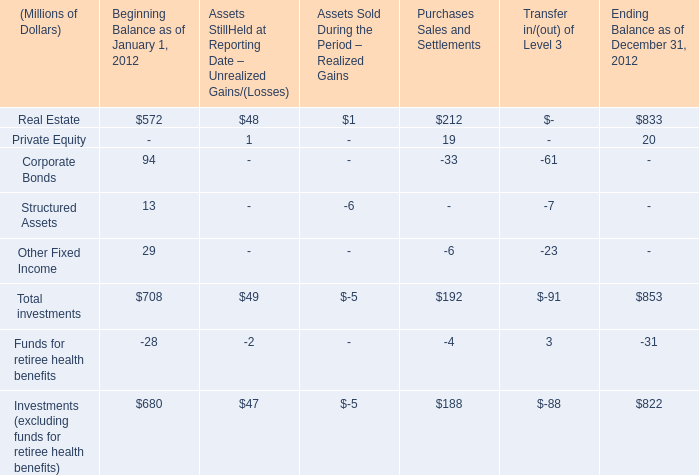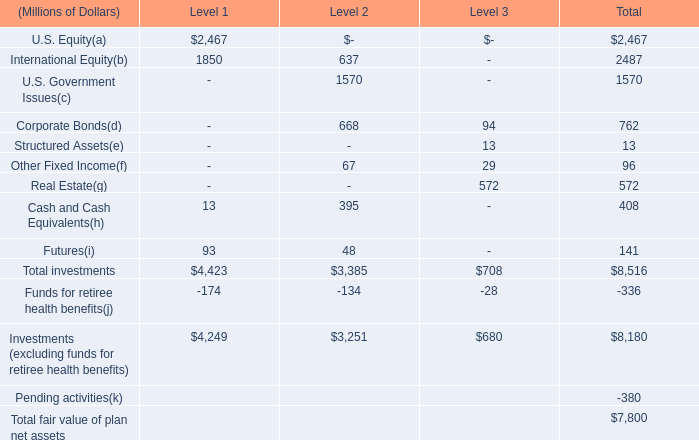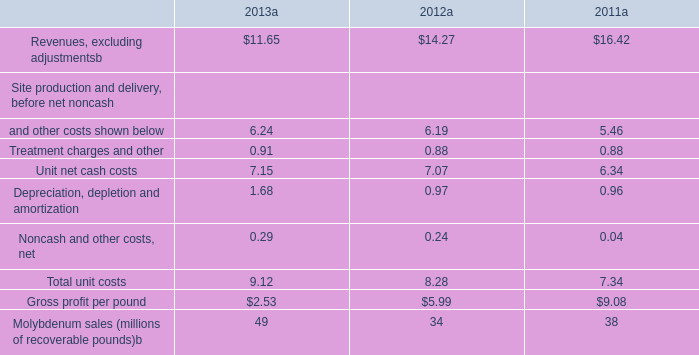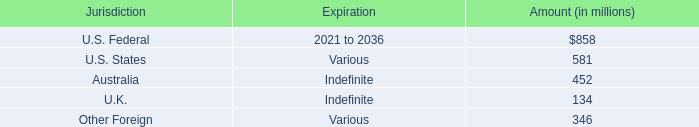What is the amount of all Real Estate that exceeds 10 % of total Real Estate in terms of Ending Balance as of December 31, 2012? (in Millions of Dollars) 
Computations: ((572 + 212) + 833)
Answer: 1617.0. 